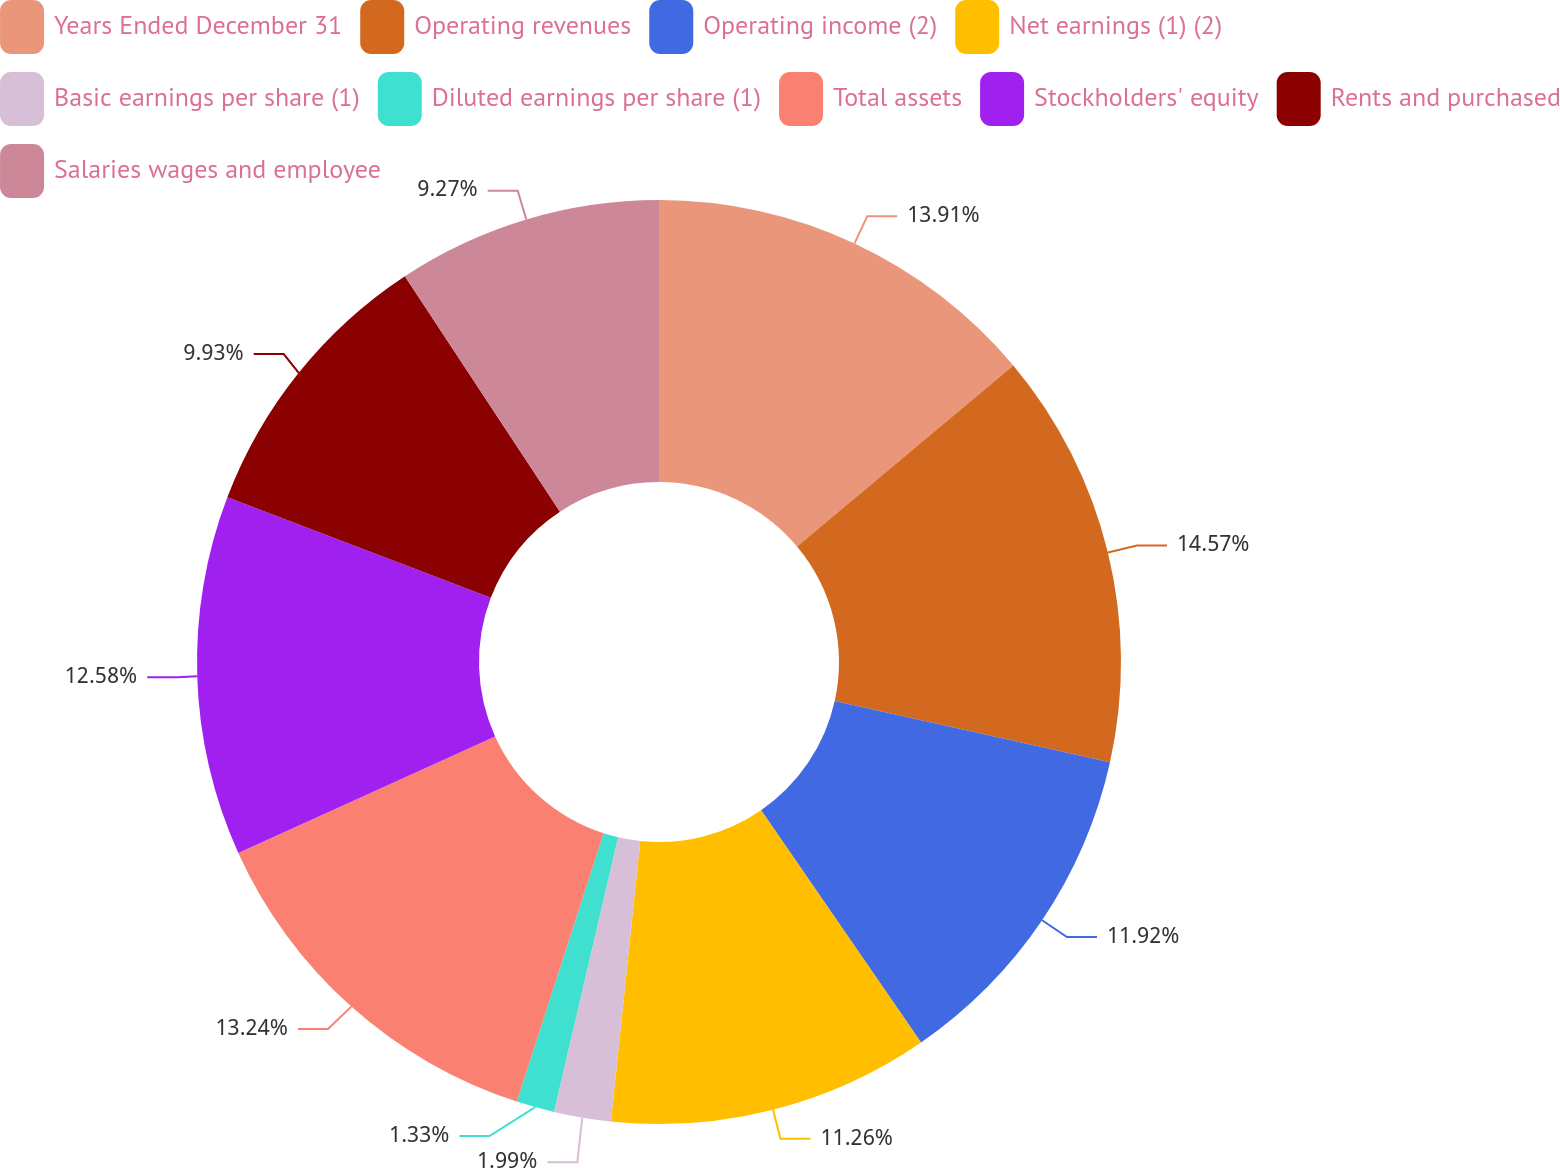Convert chart to OTSL. <chart><loc_0><loc_0><loc_500><loc_500><pie_chart><fcel>Years Ended December 31<fcel>Operating revenues<fcel>Operating income (2)<fcel>Net earnings (1) (2)<fcel>Basic earnings per share (1)<fcel>Diluted earnings per share (1)<fcel>Total assets<fcel>Stockholders' equity<fcel>Rents and purchased<fcel>Salaries wages and employee<nl><fcel>13.91%<fcel>14.57%<fcel>11.92%<fcel>11.26%<fcel>1.99%<fcel>1.33%<fcel>13.24%<fcel>12.58%<fcel>9.93%<fcel>9.27%<nl></chart> 